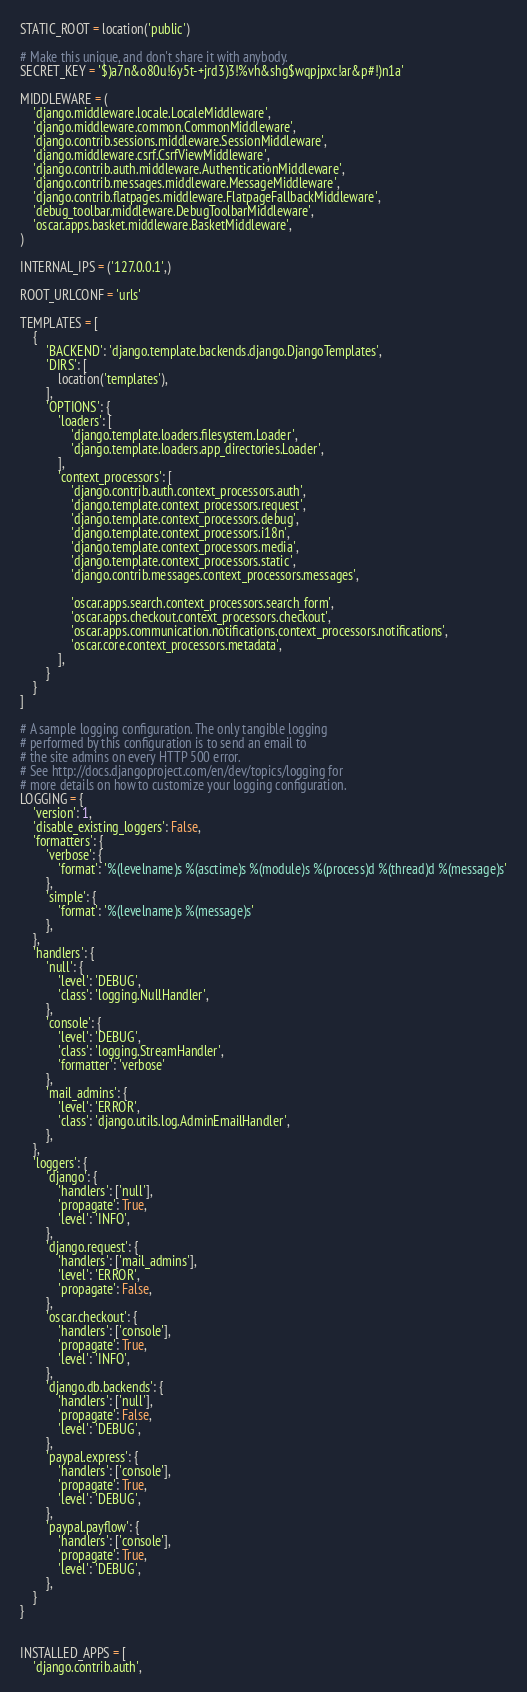Convert code to text. <code><loc_0><loc_0><loc_500><loc_500><_Python_>STATIC_ROOT = location('public')

# Make this unique, and don't share it with anybody.
SECRET_KEY = '$)a7n&o80u!6y5t-+jrd3)3!%vh&shg$wqpjpxc!ar&p#!)n1a'

MIDDLEWARE = (
    'django.middleware.locale.LocaleMiddleware',
    'django.middleware.common.CommonMiddleware',
    'django.contrib.sessions.middleware.SessionMiddleware',
    'django.middleware.csrf.CsrfViewMiddleware',
    'django.contrib.auth.middleware.AuthenticationMiddleware',
    'django.contrib.messages.middleware.MessageMiddleware',
    'django.contrib.flatpages.middleware.FlatpageFallbackMiddleware',
    'debug_toolbar.middleware.DebugToolbarMiddleware',
    'oscar.apps.basket.middleware.BasketMiddleware',
)

INTERNAL_IPS = ('127.0.0.1',)

ROOT_URLCONF = 'urls'

TEMPLATES = [
    {
        'BACKEND': 'django.template.backends.django.DjangoTemplates',
        'DIRS': [
            location('templates'),
        ],
        'OPTIONS': {
            'loaders': [
                'django.template.loaders.filesystem.Loader',
                'django.template.loaders.app_directories.Loader',
            ],
            'context_processors': [
                'django.contrib.auth.context_processors.auth',
                'django.template.context_processors.request',
                'django.template.context_processors.debug',
                'django.template.context_processors.i18n',
                'django.template.context_processors.media',
                'django.template.context_processors.static',
                'django.contrib.messages.context_processors.messages',

                'oscar.apps.search.context_processors.search_form',
                'oscar.apps.checkout.context_processors.checkout',
                'oscar.apps.communication.notifications.context_processors.notifications',
                'oscar.core.context_processors.metadata',
            ],
        }
    }
]

# A sample logging configuration. The only tangible logging
# performed by this configuration is to send an email to
# the site admins on every HTTP 500 error.
# See http://docs.djangoproject.com/en/dev/topics/logging for
# more details on how to customize your logging configuration.
LOGGING = {
    'version': 1,
    'disable_existing_loggers': False,
    'formatters': {
        'verbose': {
            'format': '%(levelname)s %(asctime)s %(module)s %(process)d %(thread)d %(message)s'
        },
        'simple': {
            'format': '%(levelname)s %(message)s'
        },
    },
    'handlers': {
        'null': {
            'level': 'DEBUG',
            'class': 'logging.NullHandler',
        },
        'console': {
            'level': 'DEBUG',
            'class': 'logging.StreamHandler',
            'formatter': 'verbose'
        },
        'mail_admins': {
            'level': 'ERROR',
            'class': 'django.utils.log.AdminEmailHandler',
        },
    },
    'loggers': {
        'django': {
            'handlers': ['null'],
            'propagate': True,
            'level': 'INFO',
        },
        'django.request': {
            'handlers': ['mail_admins'],
            'level': 'ERROR',
            'propagate': False,
        },
        'oscar.checkout': {
            'handlers': ['console'],
            'propagate': True,
            'level': 'INFO',
        },
        'django.db.backends': {
            'handlers': ['null'],
            'propagate': False,
            'level': 'DEBUG',
        },
        'paypal.express': {
            'handlers': ['console'],
            'propagate': True,
            'level': 'DEBUG',
        },
        'paypal.payflow': {
            'handlers': ['console'],
            'propagate': True,
            'level': 'DEBUG',
        },
    }
}


INSTALLED_APPS = [
    'django.contrib.auth',</code> 